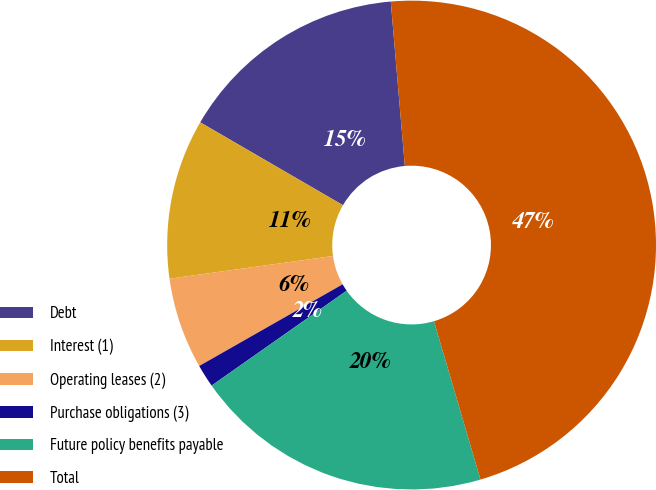Convert chart to OTSL. <chart><loc_0><loc_0><loc_500><loc_500><pie_chart><fcel>Debt<fcel>Interest (1)<fcel>Operating leases (2)<fcel>Purchase obligations (3)<fcel>Future policy benefits payable<fcel>Total<nl><fcel>15.27%<fcel>10.57%<fcel>6.04%<fcel>1.51%<fcel>19.8%<fcel>46.81%<nl></chart> 